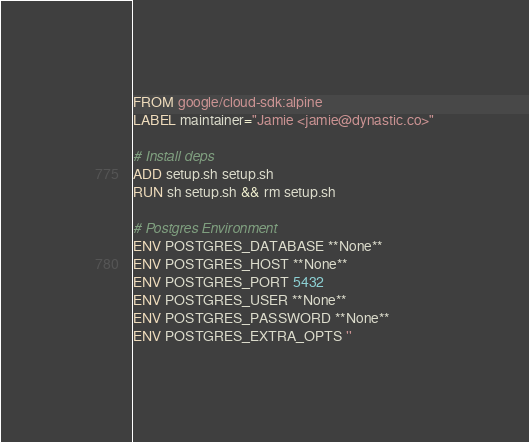<code> <loc_0><loc_0><loc_500><loc_500><_Dockerfile_>FROM google/cloud-sdk:alpine
LABEL maintainer="Jamie <jamie@dynastic.co>"

# Install deps
ADD setup.sh setup.sh
RUN sh setup.sh && rm setup.sh

# Postgres Environment
ENV POSTGRES_DATABASE **None**
ENV POSTGRES_HOST **None**
ENV POSTGRES_PORT 5432
ENV POSTGRES_USER **None**
ENV POSTGRES_PASSWORD **None**
ENV POSTGRES_EXTRA_OPTS ''
</code> 